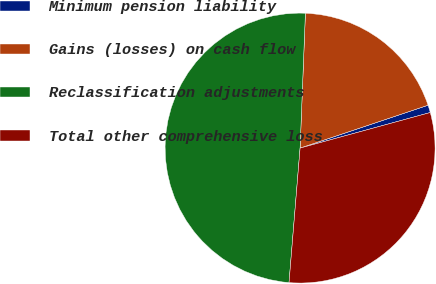Convert chart. <chart><loc_0><loc_0><loc_500><loc_500><pie_chart><fcel>Minimum pension liability<fcel>Gains (losses) on cash flow<fcel>Reclassification adjustments<fcel>Total other comprehensive loss<nl><fcel>0.9%<fcel>19.23%<fcel>49.32%<fcel>30.55%<nl></chart> 